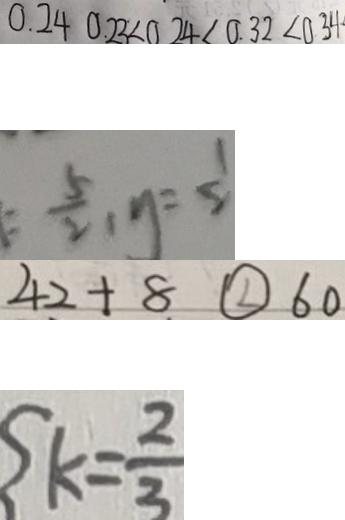<formula> <loc_0><loc_0><loc_500><loc_500>0 . 2 4 0 . 2 3 < 0 . 2 4 < 0 . 3 2 < 0 . 3 4 
 = \frac { 5 } { 2 } , y = \frac { 1 } { 2 } 
 4 2 + 8 \textcircled { < } 6 0 
 k = \frac { 2 } { 3 }</formula> 